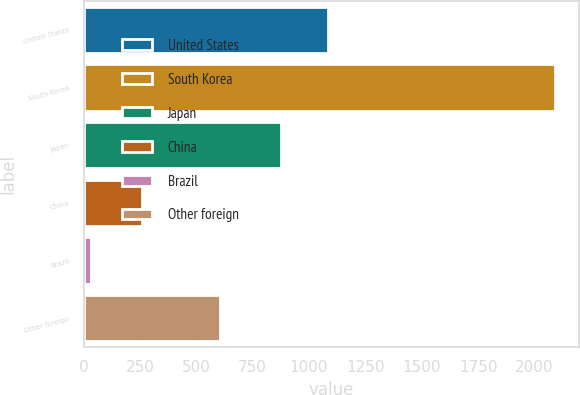Convert chart. <chart><loc_0><loc_0><loc_500><loc_500><bar_chart><fcel>United States<fcel>South Korea<fcel>Japan<fcel>China<fcel>Brazil<fcel>Other foreign<nl><fcel>1083<fcel>2091<fcel>877<fcel>260<fcel>31<fcel>605<nl></chart> 